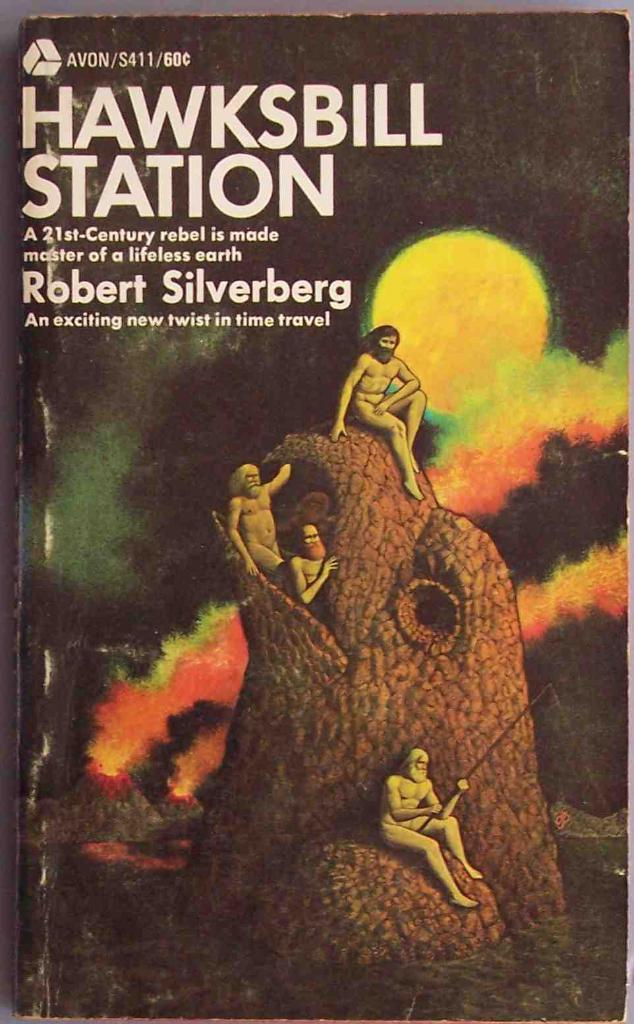Who is the author of this book?
Offer a terse response. Robert silverberg. 